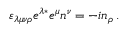<formula> <loc_0><loc_0><loc_500><loc_500>\varepsilon _ { \lambda \mu \nu \rho } e ^ { \lambda \ast } e ^ { \mu } n ^ { \nu } = - i n _ { \rho } \, .</formula> 